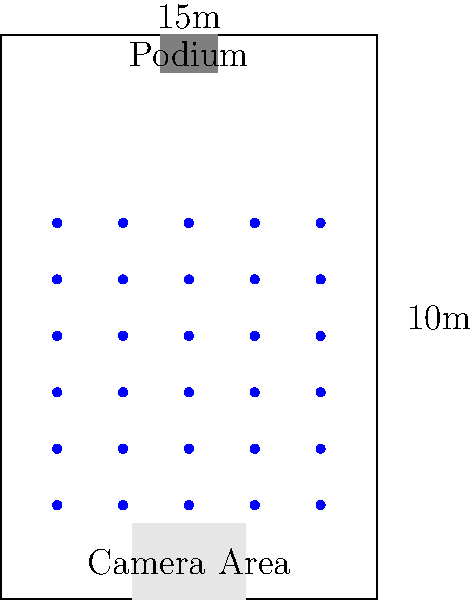As the PR director of a major football team, you're tasked with optimizing the press conference room layout. Given the floor plan above, which shows a room of dimensions 10m x 15m with a podium at one end and a camera area at the other, what is the maximum number of chairs that can be placed in the remaining space if each chair requires a $1\text{m}^2$ area (including space for movement)? To solve this problem, we'll follow these steps:

1. Calculate the total area of the room:
   $A_{total} = 10\text{m} \times 15\text{m} = 150\text{m}^2$

2. Calculate the area occupied by the podium:
   $A_{podium} = 1.5\text{m} \times 1\text{m} = 1.5\text{m}^2$

3. Calculate the area occupied by the camera area:
   $A_{camera} = 3\text{m} \times 2\text{m} = 6\text{m}^2$

4. Calculate the remaining area for chairs:
   $A_{remaining} = A_{total} - A_{podium} - A_{camera}$
   $A_{remaining} = 150\text{m}^2 - 1.5\text{m}^2 - 6\text{m}^2 = 142.5\text{m}^2$

5. Calculate the maximum number of chairs:
   Since each chair requires $1\text{m}^2$, we can fit as many chairs as we have square meters of remaining space. However, we need to round down to ensure we don't exceed the available space.

   $N_{chairs} = \lfloor A_{remaining} \rfloor = \lfloor 142.5 \rfloor = 142$

Therefore, the maximum number of chairs that can be placed in the remaining space is 142.
Answer: 142 chairs 